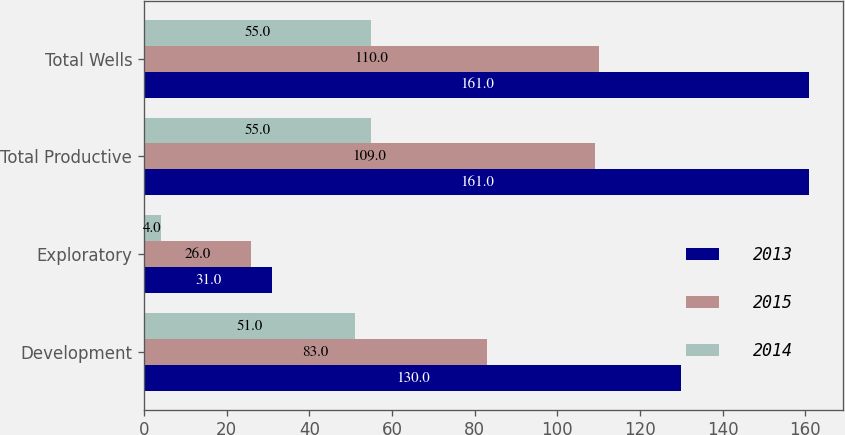<chart> <loc_0><loc_0><loc_500><loc_500><stacked_bar_chart><ecel><fcel>Development<fcel>Exploratory<fcel>Total Productive<fcel>Total Wells<nl><fcel>2013<fcel>130<fcel>31<fcel>161<fcel>161<nl><fcel>2015<fcel>83<fcel>26<fcel>109<fcel>110<nl><fcel>2014<fcel>51<fcel>4<fcel>55<fcel>55<nl></chart> 